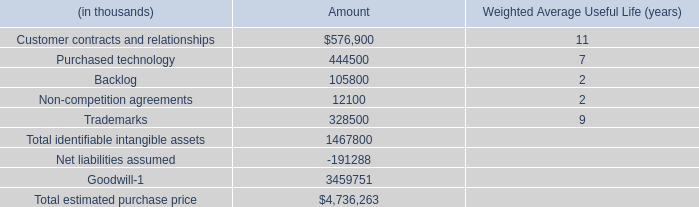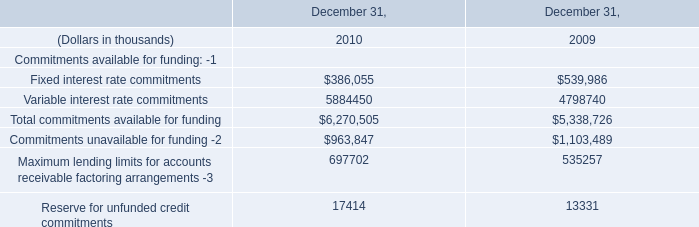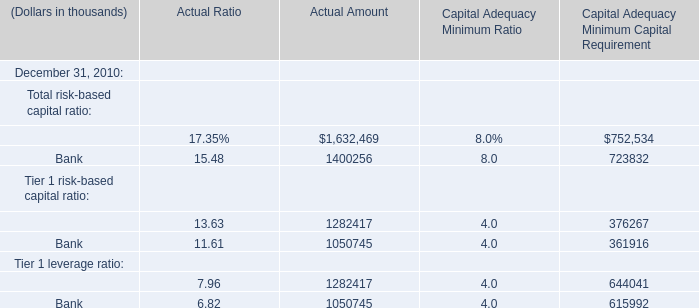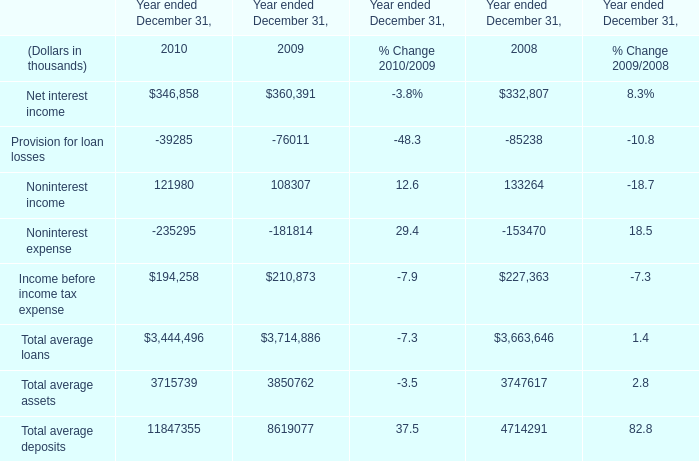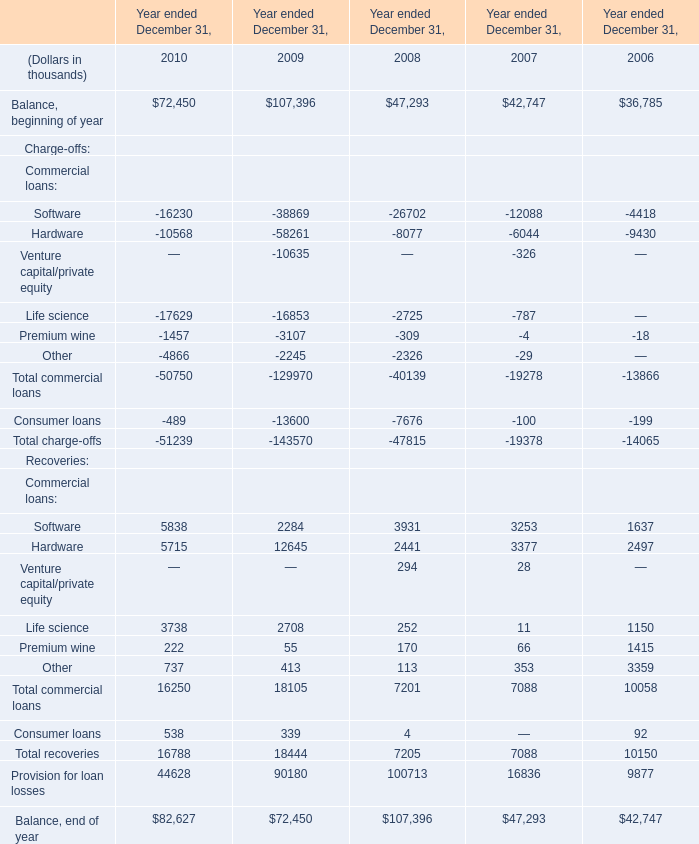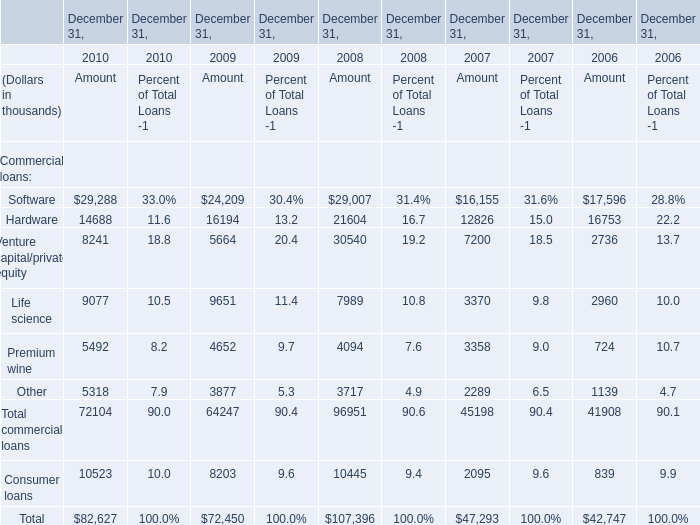At December 31,what year is Total commercial loans greater than 90000 thousand? 
Answer: 2008. 